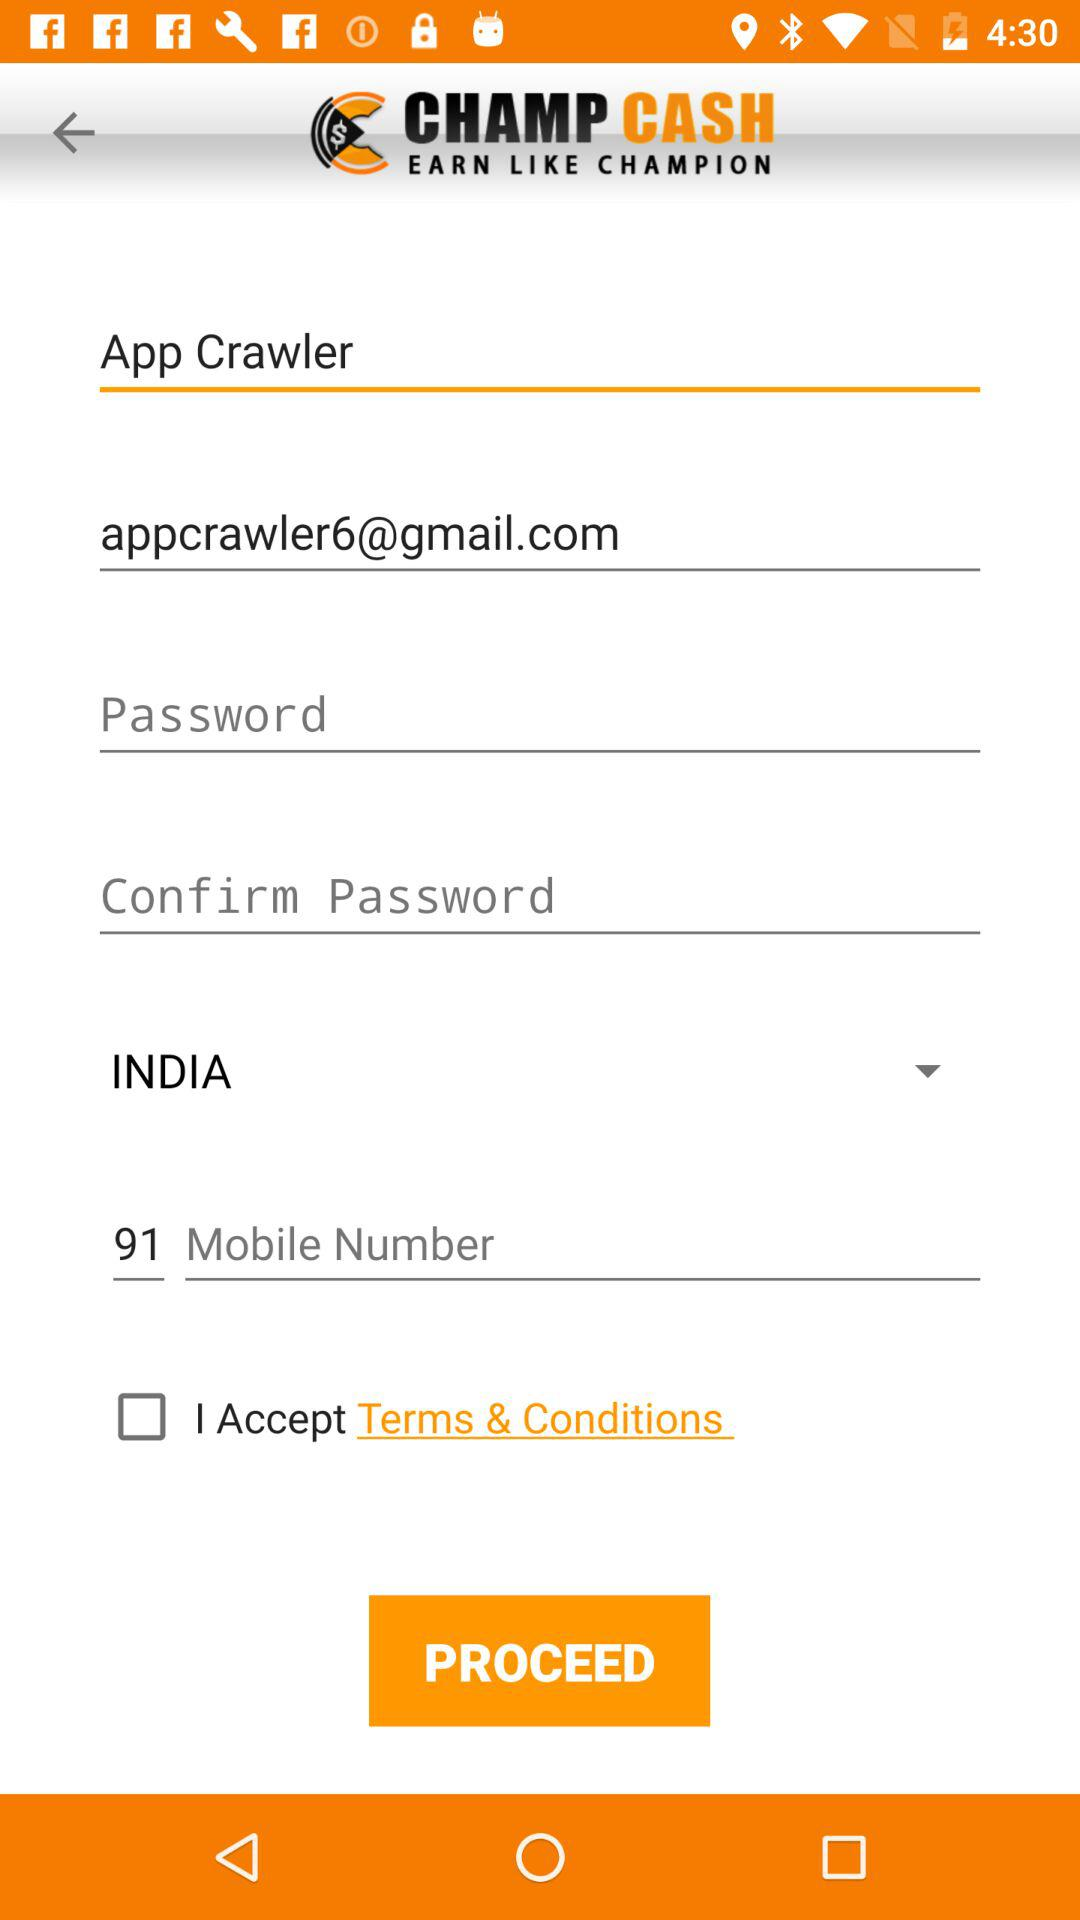What is the status of the option that includes acceptance to the "Terms & Conditions"? The status of the option that includes acceptance to the "Terms & Conditions" is "off". 